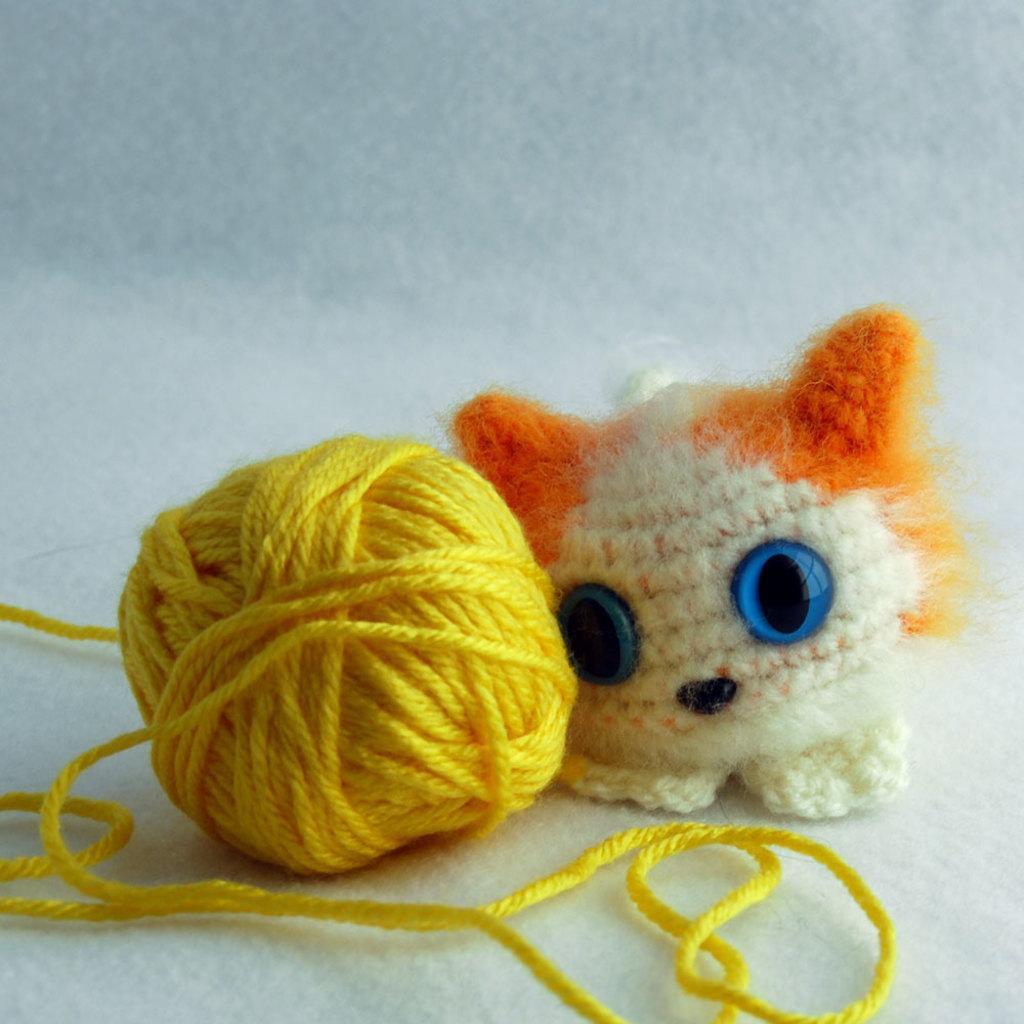Can you describe this image briefly? In the picture we can see yellow color thread roll and there is toy which is on the surface. 